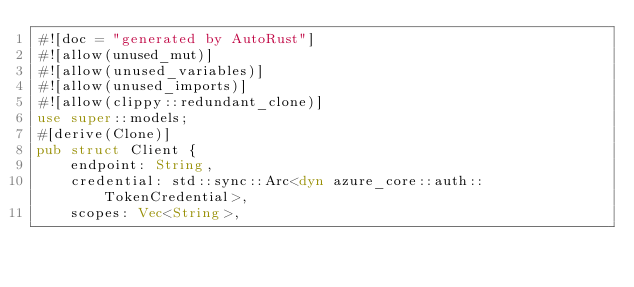<code> <loc_0><loc_0><loc_500><loc_500><_Rust_>#![doc = "generated by AutoRust"]
#![allow(unused_mut)]
#![allow(unused_variables)]
#![allow(unused_imports)]
#![allow(clippy::redundant_clone)]
use super::models;
#[derive(Clone)]
pub struct Client {
    endpoint: String,
    credential: std::sync::Arc<dyn azure_core::auth::TokenCredential>,
    scopes: Vec<String>,</code> 